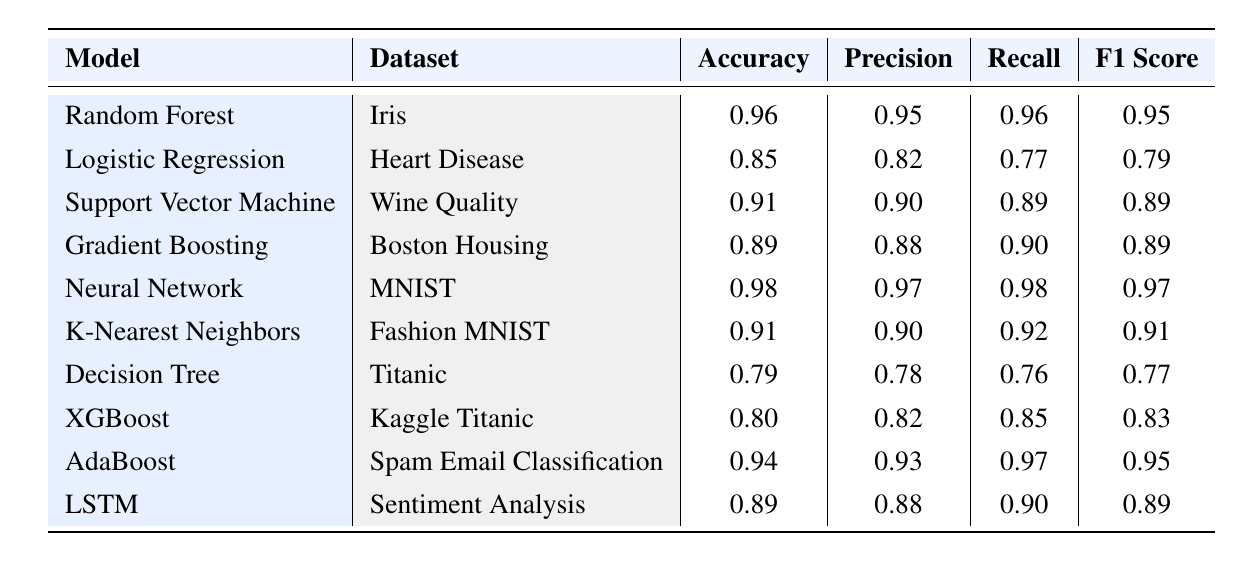What is the accuracy of the Neural Network model? The table lists the accuracy of the Neural Network model as 0.98.
Answer: 0.98 Which model achieved the highest F1 Score? The highest F1 Score in the table is 0.97, achieved by the Neural Network model.
Answer: Neural Network What is the average Precision score across all models? The Precision scores are 0.95, 0.82, 0.90, 0.88, 0.97, 0.90, 0.78, 0.82, 0.93, and 0.88. Adding these gives 8.95, and there are 10 models, so the average is 8.95/10 = 0.895.
Answer: 0.895 Which model has the lowest Recall value? By checking the Recall values in the table, the model with the lowest Recall is the Decision Tree with a Recall of 0.76.
Answer: Decision Tree Is the Precision of the Logistic Regression model greater than its Recall? The Precision of Logistic Regression is 0.82 and the Recall is 0.77. Since 0.82 > 0.77, the statement is true.
Answer: Yes What is the difference in accuracy between the Random Forest and K-Nearest Neighbors models? The accuracy of Random Forest is 0.96, and for K-Nearest Neighbors, it is 0.91. The difference is 0.96 - 0.91 = 0.05.
Answer: 0.05 Which model had a better F1 Score than its Precision? By inspecting the table, the Logistic Regression has an F1 Score of 0.79 which is less than its Precision of 0.82. No other model has this property, thus it is unique.
Answer: Logistic Regression What is the cumulative accuracy of all models listed? The accuracy values sum up to 0.96 + 0.85 + 0.91 + 0.89 + 0.98 + 0.91 + 0.79 + 0.80 + 0.94 + 0.89 = 9.02.
Answer: 9.02 Is the F1 Score of the AdaBoost model higher than the average F1 Score? The F1 Score of AdaBoost is 0.95. The average F1 Score across all models is calculated by summing them (0.95 + 0.79 + 0.89 + 0.89 + 0.97 + 0.91 + 0.77 + 0.83 + 0.95 + 0.89)/10 = 0.886. Since 0.95 > 0.886, the statement is true.
Answer: Yes Which dataset had the lowest performance in terms of accuracy? The Titanic dataset has the lowest accuracy value of 0.79 among all listed models.
Answer: Titanic 